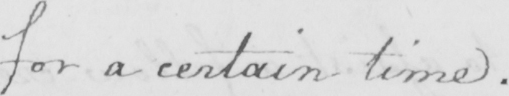Can you tell me what this handwritten text says? for a certain time . 